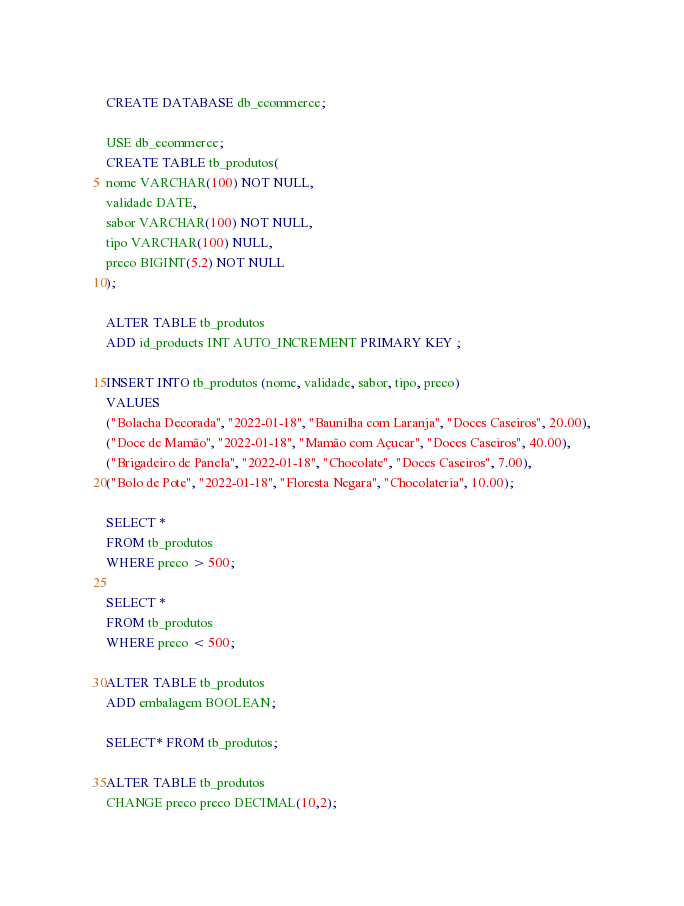Convert code to text. <code><loc_0><loc_0><loc_500><loc_500><_SQL_>CREATE DATABASE db_ecommerce;

USE db_ecommerce;
CREATE TABLE tb_produtos(
nome VARCHAR(100) NOT NULL, 
validade DATE, 
sabor VARCHAR(100) NOT NULL, 
tipo VARCHAR(100) NULL,
preco BIGINT(5.2) NOT NULL
);

ALTER TABLE tb_produtos
ADD id_products INT AUTO_INCREMENT PRIMARY KEY ;

INSERT INTO tb_produtos (nome, validade, sabor, tipo, preco)
VALUES
("Bolacha Decorada", "2022-01-18", "Baunilha com Laranja", "Doces Caseiros", 20.00),
("Doce de Mamão", "2022-01-18", "Mamão com Açucar", "Doces Caseiros", 40.00),
("Brigadeiro de Panela", "2022-01-18", "Chocolate", "Doces Caseiros", 7.00),
("Bolo de Pote", "2022-01-18", "Floresta Negara", "Chocolateria", 10.00);

SELECT * 
FROM tb_produtos
WHERE preco > 500;

SELECT * 
FROM tb_produtos
WHERE preco < 500;

ALTER TABLE tb_produtos
ADD embalagem BOOLEAN;

SELECT* FROM tb_produtos;

ALTER TABLE tb_produtos
CHANGE preco preco DECIMAL(10,2);</code> 